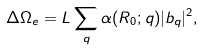Convert formula to latex. <formula><loc_0><loc_0><loc_500><loc_500>\Delta \Omega _ { e } = L \sum _ { q } \alpha ( R _ { 0 } ; q ) | b _ { q } | ^ { 2 } ,</formula> 